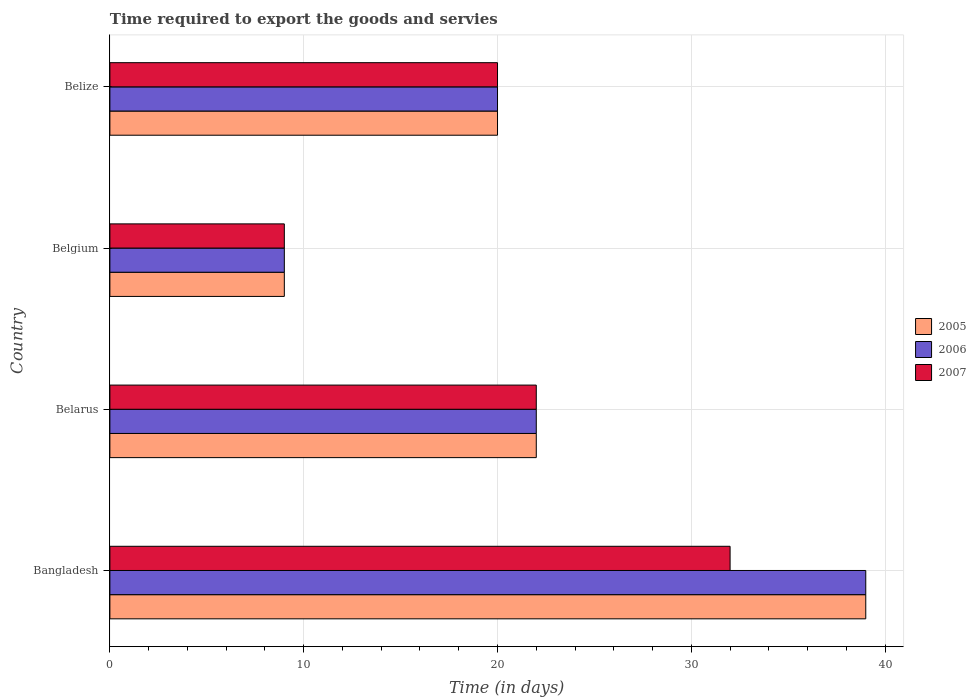How many different coloured bars are there?
Keep it short and to the point. 3. How many groups of bars are there?
Ensure brevity in your answer.  4. How many bars are there on the 2nd tick from the top?
Provide a succinct answer. 3. How many bars are there on the 4th tick from the bottom?
Your answer should be compact. 3. What is the label of the 1st group of bars from the top?
Provide a succinct answer. Belize. In how many cases, is the number of bars for a given country not equal to the number of legend labels?
Provide a succinct answer. 0. Across all countries, what is the maximum number of days required to export the goods and services in 2006?
Keep it short and to the point. 39. Across all countries, what is the minimum number of days required to export the goods and services in 2005?
Provide a short and direct response. 9. In which country was the number of days required to export the goods and services in 2007 maximum?
Your answer should be very brief. Bangladesh. In which country was the number of days required to export the goods and services in 2007 minimum?
Offer a terse response. Belgium. In how many countries, is the number of days required to export the goods and services in 2005 greater than 4 days?
Give a very brief answer. 4. What is the ratio of the number of days required to export the goods and services in 2005 in Bangladesh to that in Belarus?
Provide a short and direct response. 1.77. How many countries are there in the graph?
Provide a succinct answer. 4. What is the difference between two consecutive major ticks on the X-axis?
Your answer should be compact. 10. How many legend labels are there?
Keep it short and to the point. 3. What is the title of the graph?
Offer a very short reply. Time required to export the goods and servies. Does "2010" appear as one of the legend labels in the graph?
Your answer should be very brief. No. What is the label or title of the X-axis?
Offer a terse response. Time (in days). What is the Time (in days) in 2005 in Bangladesh?
Your answer should be compact. 39. What is the Time (in days) of 2006 in Bangladesh?
Offer a very short reply. 39. What is the Time (in days) in 2007 in Belarus?
Your answer should be very brief. 22. What is the Time (in days) of 2006 in Belgium?
Make the answer very short. 9. What is the Time (in days) of 2007 in Belize?
Your response must be concise. 20. Across all countries, what is the maximum Time (in days) of 2006?
Offer a very short reply. 39. Across all countries, what is the minimum Time (in days) in 2007?
Provide a succinct answer. 9. What is the total Time (in days) in 2005 in the graph?
Your answer should be very brief. 90. What is the total Time (in days) in 2006 in the graph?
Provide a short and direct response. 90. What is the total Time (in days) of 2007 in the graph?
Keep it short and to the point. 83. What is the difference between the Time (in days) of 2005 in Bangladesh and that in Belarus?
Ensure brevity in your answer.  17. What is the difference between the Time (in days) in 2006 in Bangladesh and that in Belarus?
Offer a very short reply. 17. What is the difference between the Time (in days) in 2007 in Bangladesh and that in Belarus?
Your answer should be compact. 10. What is the difference between the Time (in days) in 2005 in Bangladesh and that in Belgium?
Provide a short and direct response. 30. What is the difference between the Time (in days) in 2006 in Bangladesh and that in Belgium?
Your answer should be very brief. 30. What is the difference between the Time (in days) of 2005 in Bangladesh and that in Belize?
Give a very brief answer. 19. What is the difference between the Time (in days) of 2006 in Bangladesh and that in Belize?
Offer a very short reply. 19. What is the difference between the Time (in days) of 2005 in Belarus and that in Belgium?
Your response must be concise. 13. What is the difference between the Time (in days) of 2006 in Belarus and that in Belgium?
Offer a terse response. 13. What is the difference between the Time (in days) of 2006 in Belarus and that in Belize?
Provide a short and direct response. 2. What is the difference between the Time (in days) in 2006 in Belgium and that in Belize?
Provide a succinct answer. -11. What is the difference between the Time (in days) of 2005 in Bangladesh and the Time (in days) of 2007 in Belarus?
Provide a short and direct response. 17. What is the difference between the Time (in days) in 2006 in Bangladesh and the Time (in days) in 2007 in Belarus?
Provide a short and direct response. 17. What is the difference between the Time (in days) of 2005 in Bangladesh and the Time (in days) of 2006 in Belgium?
Provide a short and direct response. 30. What is the difference between the Time (in days) in 2006 in Bangladesh and the Time (in days) in 2007 in Belgium?
Provide a short and direct response. 30. What is the difference between the Time (in days) of 2005 in Bangladesh and the Time (in days) of 2007 in Belize?
Your answer should be compact. 19. What is the difference between the Time (in days) of 2006 in Bangladesh and the Time (in days) of 2007 in Belize?
Provide a short and direct response. 19. What is the difference between the Time (in days) of 2005 in Belarus and the Time (in days) of 2007 in Belgium?
Your response must be concise. 13. What is the difference between the Time (in days) of 2006 in Belarus and the Time (in days) of 2007 in Belgium?
Your response must be concise. 13. What is the difference between the Time (in days) in 2005 in Belarus and the Time (in days) in 2006 in Belize?
Offer a very short reply. 2. What is the difference between the Time (in days) of 2005 in Belarus and the Time (in days) of 2007 in Belize?
Provide a short and direct response. 2. What is the difference between the Time (in days) in 2005 in Belgium and the Time (in days) in 2007 in Belize?
Your answer should be very brief. -11. What is the difference between the Time (in days) in 2006 in Belgium and the Time (in days) in 2007 in Belize?
Your answer should be compact. -11. What is the average Time (in days) of 2006 per country?
Make the answer very short. 22.5. What is the average Time (in days) of 2007 per country?
Provide a short and direct response. 20.75. What is the difference between the Time (in days) of 2005 and Time (in days) of 2006 in Bangladesh?
Provide a succinct answer. 0. What is the difference between the Time (in days) of 2005 and Time (in days) of 2007 in Bangladesh?
Ensure brevity in your answer.  7. What is the difference between the Time (in days) of 2006 and Time (in days) of 2007 in Belarus?
Offer a terse response. 0. What is the difference between the Time (in days) in 2005 and Time (in days) in 2006 in Belgium?
Make the answer very short. 0. What is the difference between the Time (in days) of 2005 and Time (in days) of 2007 in Belgium?
Keep it short and to the point. 0. What is the difference between the Time (in days) of 2006 and Time (in days) of 2007 in Belgium?
Provide a short and direct response. 0. What is the difference between the Time (in days) of 2005 and Time (in days) of 2006 in Belize?
Give a very brief answer. 0. What is the difference between the Time (in days) of 2006 and Time (in days) of 2007 in Belize?
Your response must be concise. 0. What is the ratio of the Time (in days) in 2005 in Bangladesh to that in Belarus?
Offer a very short reply. 1.77. What is the ratio of the Time (in days) in 2006 in Bangladesh to that in Belarus?
Your answer should be very brief. 1.77. What is the ratio of the Time (in days) of 2007 in Bangladesh to that in Belarus?
Give a very brief answer. 1.45. What is the ratio of the Time (in days) in 2005 in Bangladesh to that in Belgium?
Your response must be concise. 4.33. What is the ratio of the Time (in days) of 2006 in Bangladesh to that in Belgium?
Make the answer very short. 4.33. What is the ratio of the Time (in days) of 2007 in Bangladesh to that in Belgium?
Your answer should be compact. 3.56. What is the ratio of the Time (in days) in 2005 in Bangladesh to that in Belize?
Your response must be concise. 1.95. What is the ratio of the Time (in days) in 2006 in Bangladesh to that in Belize?
Your answer should be compact. 1.95. What is the ratio of the Time (in days) of 2005 in Belarus to that in Belgium?
Your answer should be compact. 2.44. What is the ratio of the Time (in days) of 2006 in Belarus to that in Belgium?
Make the answer very short. 2.44. What is the ratio of the Time (in days) of 2007 in Belarus to that in Belgium?
Your answer should be very brief. 2.44. What is the ratio of the Time (in days) of 2006 in Belarus to that in Belize?
Your response must be concise. 1.1. What is the ratio of the Time (in days) of 2005 in Belgium to that in Belize?
Offer a very short reply. 0.45. What is the ratio of the Time (in days) in 2006 in Belgium to that in Belize?
Offer a terse response. 0.45. What is the ratio of the Time (in days) of 2007 in Belgium to that in Belize?
Ensure brevity in your answer.  0.45. What is the difference between the highest and the second highest Time (in days) of 2007?
Make the answer very short. 10. What is the difference between the highest and the lowest Time (in days) in 2005?
Give a very brief answer. 30. What is the difference between the highest and the lowest Time (in days) of 2006?
Offer a terse response. 30. What is the difference between the highest and the lowest Time (in days) of 2007?
Offer a very short reply. 23. 